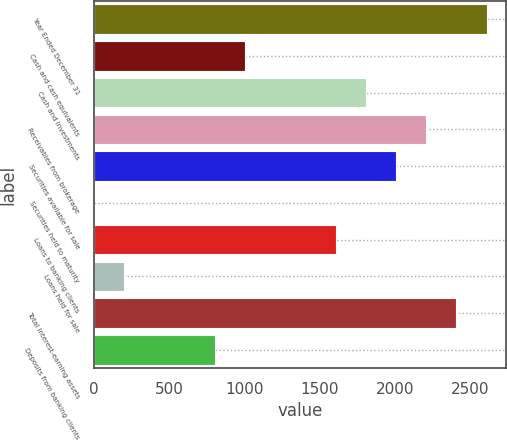<chart> <loc_0><loc_0><loc_500><loc_500><bar_chart><fcel>Year Ended December 31<fcel>Cash and cash equivalents<fcel>Cash and investments<fcel>Receivables from brokerage<fcel>Securities available for sale<fcel>Securities held to maturity<fcel>Loans to banking clients<fcel>Loans held for sale<fcel>Total interest-earning assets<fcel>Deposits from banking clients<nl><fcel>2610.1<fcel>1004.5<fcel>1807.3<fcel>2208.7<fcel>2008<fcel>1<fcel>1606.6<fcel>201.7<fcel>2409.4<fcel>803.8<nl></chart> 